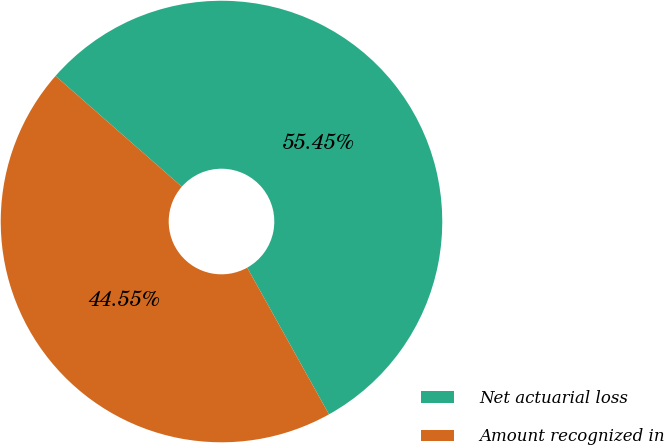Convert chart. <chart><loc_0><loc_0><loc_500><loc_500><pie_chart><fcel>Net actuarial loss<fcel>Amount recognized in<nl><fcel>55.45%<fcel>44.55%<nl></chart> 